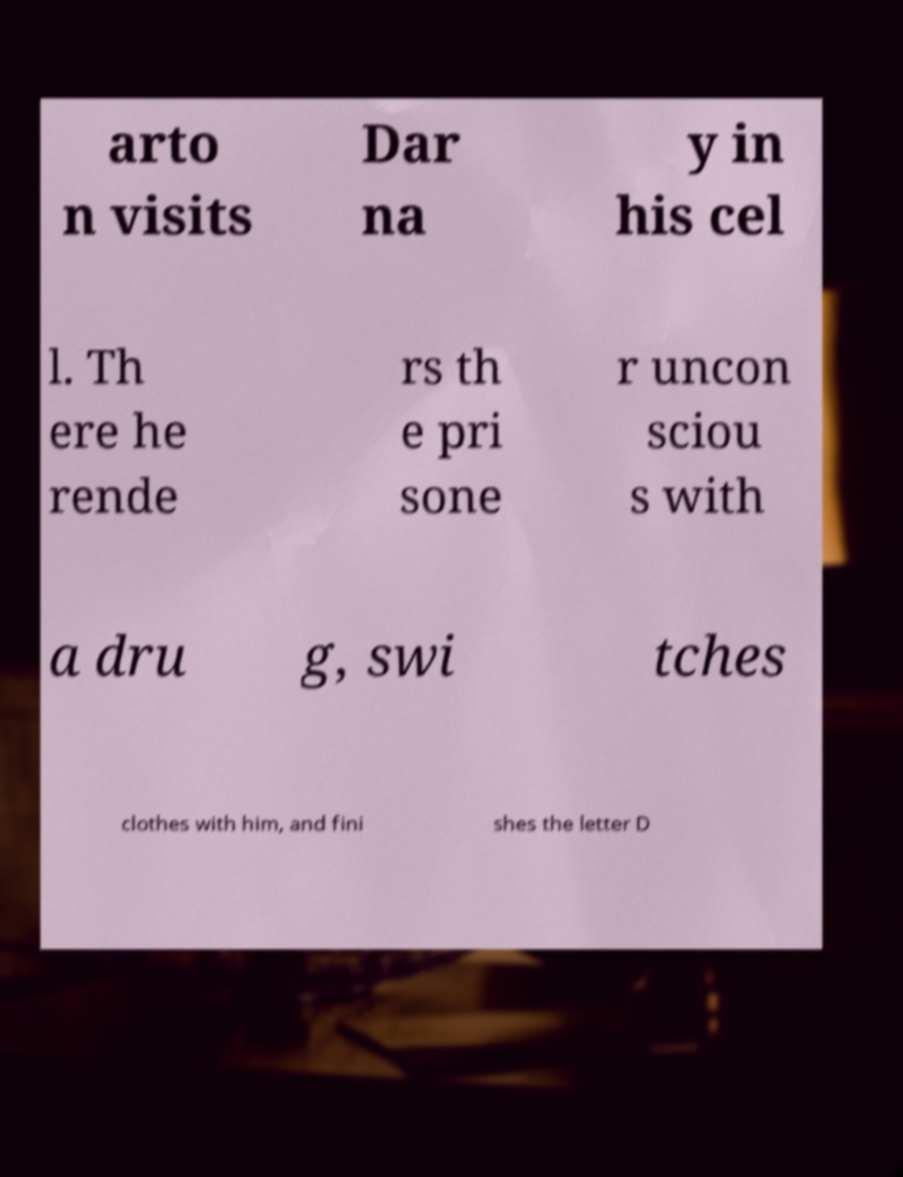There's text embedded in this image that I need extracted. Can you transcribe it verbatim? arto n visits Dar na y in his cel l. Th ere he rende rs th e pri sone r uncon sciou s with a dru g, swi tches clothes with him, and fini shes the letter D 